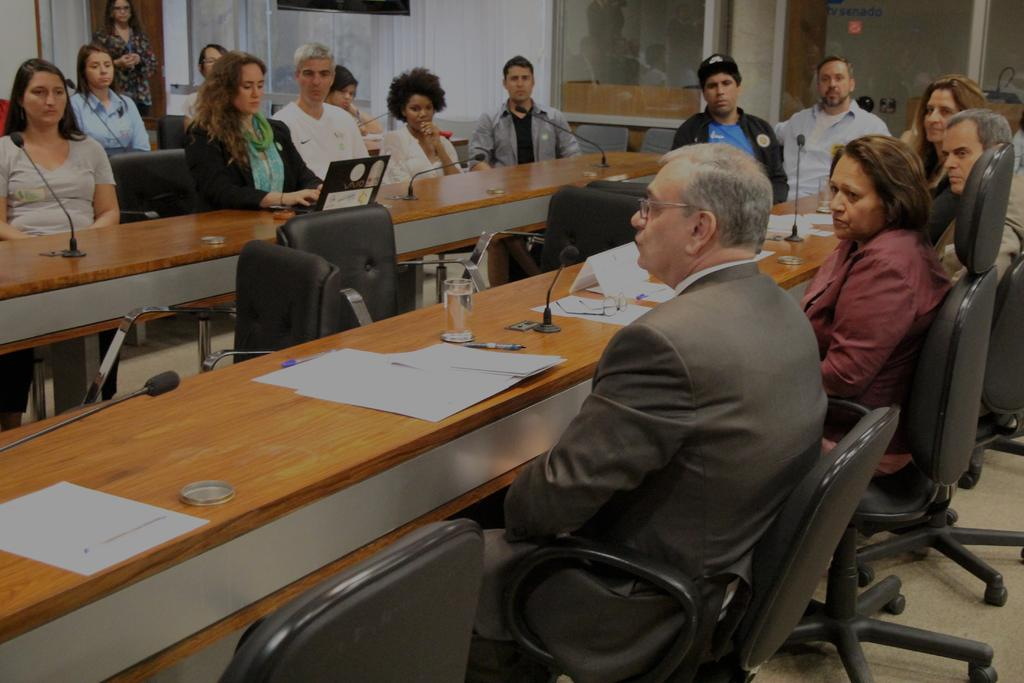What are the people in the image doing? There is a group of persons sitting on chairs in the image. What is in front of the chairs? There is a table in front of the chairs. What can be seen on the table? Papers, glasses, and a microphone are present on the table. Are there any other objects on the table? Yes, there are other objects on the table. What type of pizzas are being served on the table in the image? There are no pizzas present in the image; the table contains papers, glasses, a microphone, and other unspecified objects. 